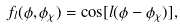Convert formula to latex. <formula><loc_0><loc_0><loc_500><loc_500>f _ { l } ( \phi , \phi _ { \chi } ) = \cos [ l ( \phi - \phi _ { \chi } ) ] ,</formula> 